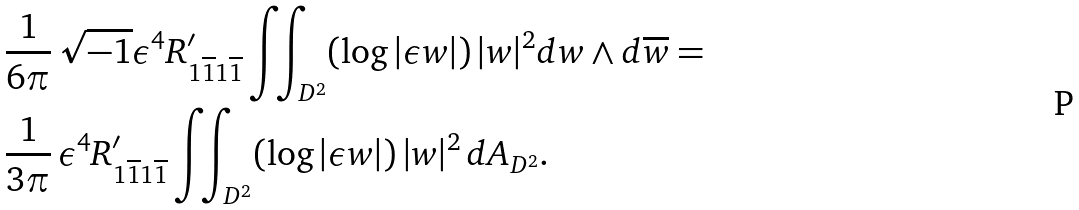Convert formula to latex. <formula><loc_0><loc_0><loc_500><loc_500>& \frac { 1 } { 6 \pi } \, \sqrt { - 1 } \epsilon ^ { 4 } R ^ { \prime } _ { 1 \overline { 1 } 1 \overline { 1 } } \iint _ { D ^ { 2 } } ( \log | \epsilon w | ) \, | w | ^ { 2 } d w \wedge d \overline { w } = \\ & \frac { 1 } { 3 \pi } \, \epsilon ^ { 4 } R ^ { \prime } _ { 1 \overline { 1 } 1 \overline { 1 } } \iint _ { D ^ { 2 } } ( \log | \epsilon w | ) \, | w | ^ { 2 } \, d A _ { D ^ { 2 } } .</formula> 